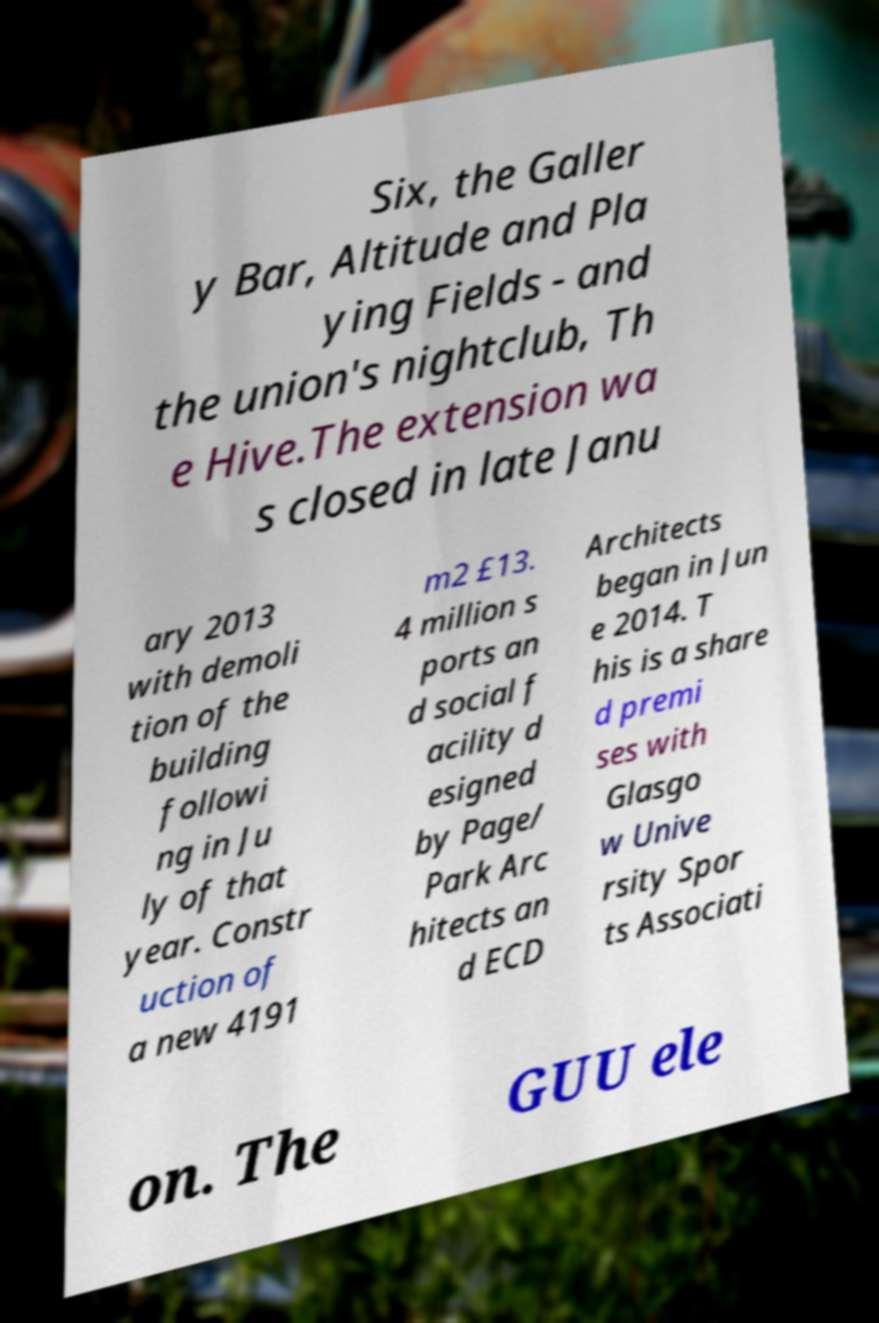Can you read and provide the text displayed in the image?This photo seems to have some interesting text. Can you extract and type it out for me? Six, the Galler y Bar, Altitude and Pla ying Fields - and the union's nightclub, Th e Hive.The extension wa s closed in late Janu ary 2013 with demoli tion of the building followi ng in Ju ly of that year. Constr uction of a new 4191 m2 £13. 4 million s ports an d social f acility d esigned by Page/ Park Arc hitects an d ECD Architects began in Jun e 2014. T his is a share d premi ses with Glasgo w Unive rsity Spor ts Associati on. The GUU ele 